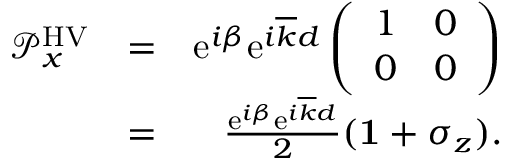<formula> <loc_0><loc_0><loc_500><loc_500>\begin{array} { r l r } { { \mathcal { P } } _ { x } ^ { H V } } & { = } & { e ^ { i \beta } e ^ { i \overline { k } d } \left ( \begin{array} { c c } { 1 } & { 0 } \\ { 0 } & { 0 } \end{array} \right ) } \\ & { = } & { \frac { e ^ { i \beta } e ^ { i \overline { k } d } } { 2 } ( { 1 } + \sigma _ { z } ) . } \end{array}</formula> 